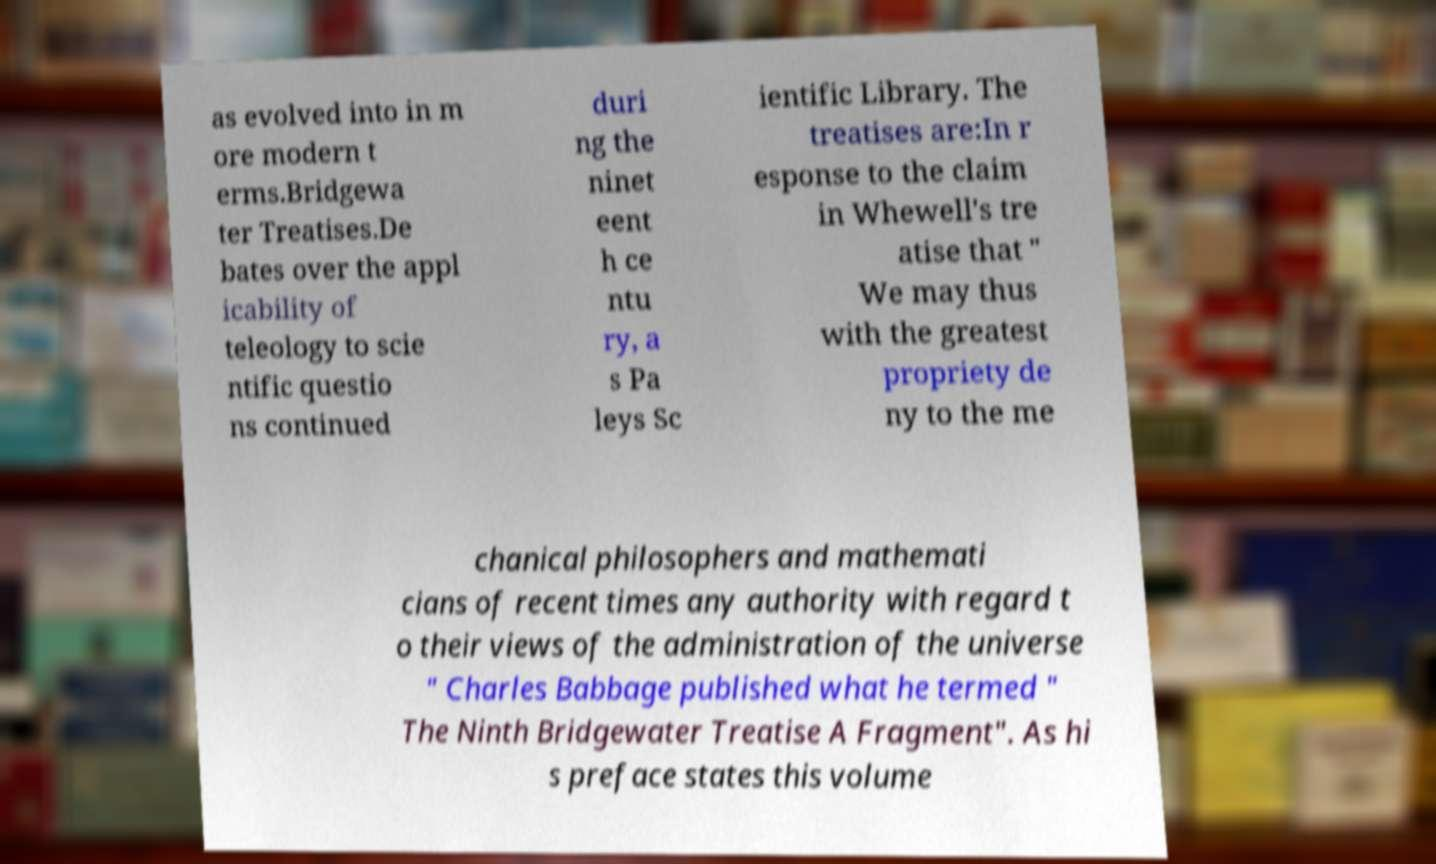Could you extract and type out the text from this image? as evolved into in m ore modern t erms.Bridgewa ter Treatises.De bates over the appl icability of teleology to scie ntific questio ns continued duri ng the ninet eent h ce ntu ry, a s Pa leys Sc ientific Library. The treatises are:In r esponse to the claim in Whewell's tre atise that " We may thus with the greatest propriety de ny to the me chanical philosophers and mathemati cians of recent times any authority with regard t o their views of the administration of the universe " Charles Babbage published what he termed " The Ninth Bridgewater Treatise A Fragment". As hi s preface states this volume 